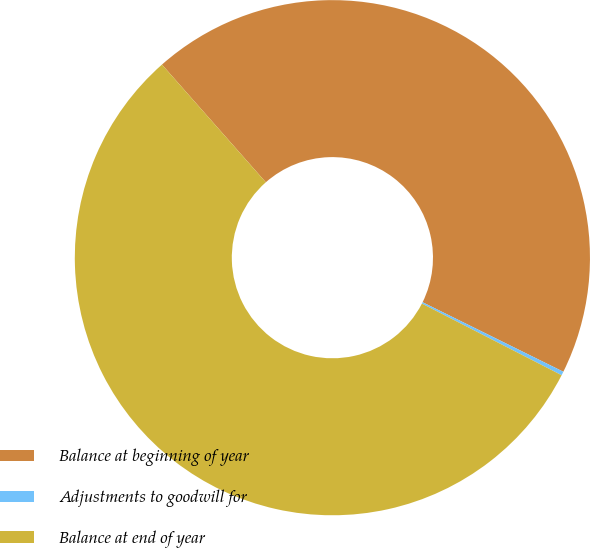<chart> <loc_0><loc_0><loc_500><loc_500><pie_chart><fcel>Balance at beginning of year<fcel>Adjustments to goodwill for<fcel>Balance at end of year<nl><fcel>43.81%<fcel>0.24%<fcel>55.95%<nl></chart> 